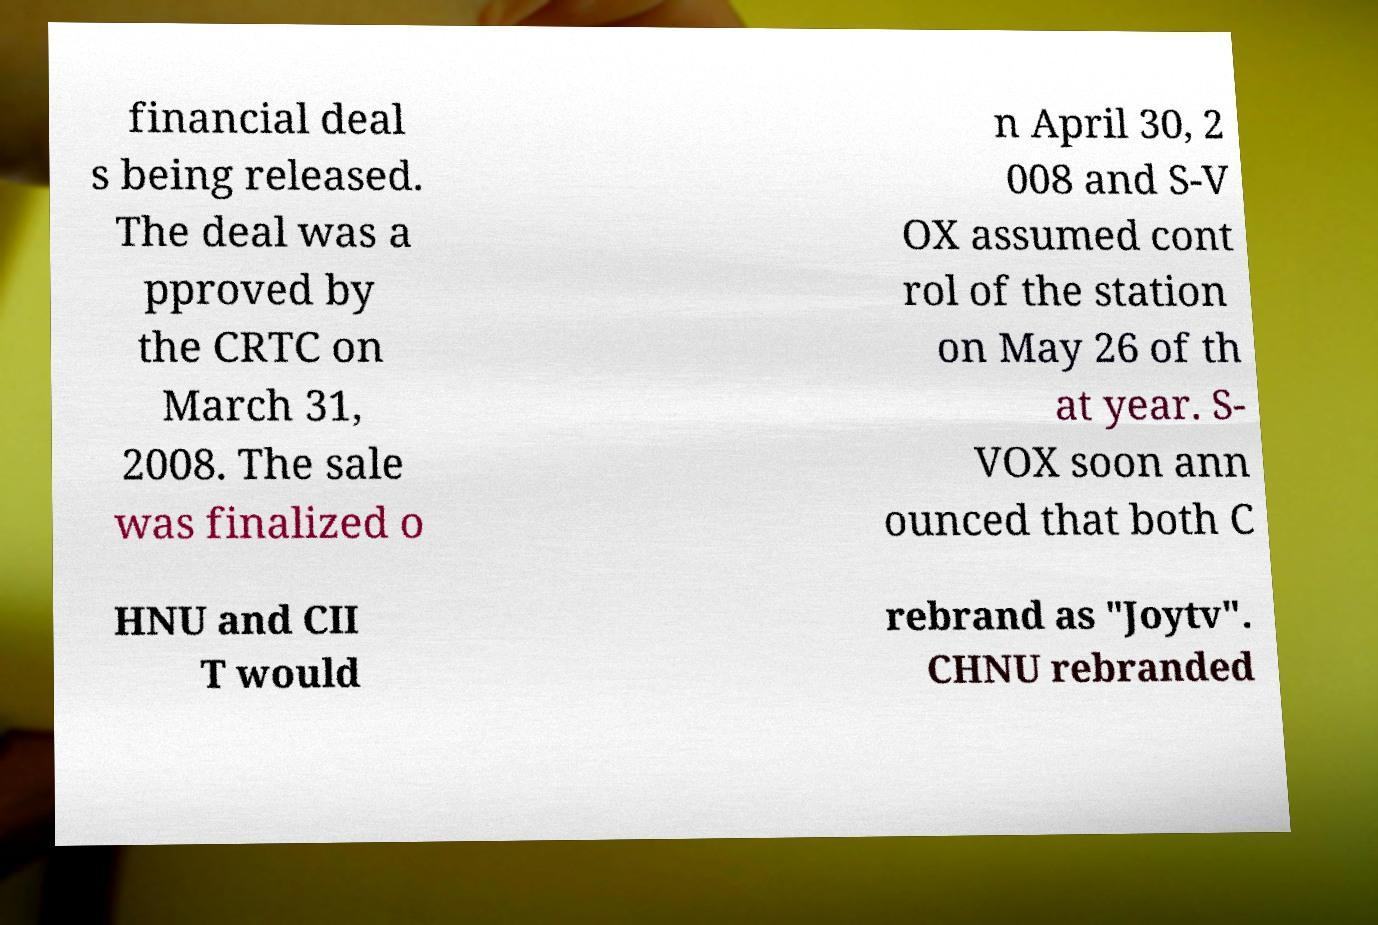There's text embedded in this image that I need extracted. Can you transcribe it verbatim? financial deal s being released. The deal was a pproved by the CRTC on March 31, 2008. The sale was finalized o n April 30, 2 008 and S-V OX assumed cont rol of the station on May 26 of th at year. S- VOX soon ann ounced that both C HNU and CII T would rebrand as "Joytv". CHNU rebranded 